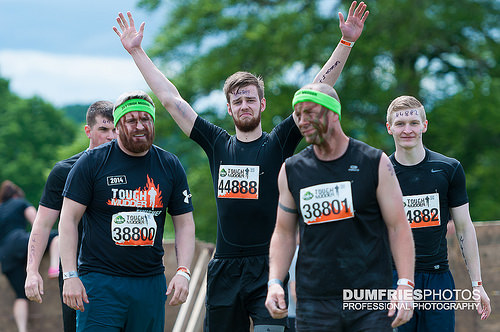<image>
Is there a man in front of the man? Yes. The man is positioned in front of the man, appearing closer to the camera viewpoint. 